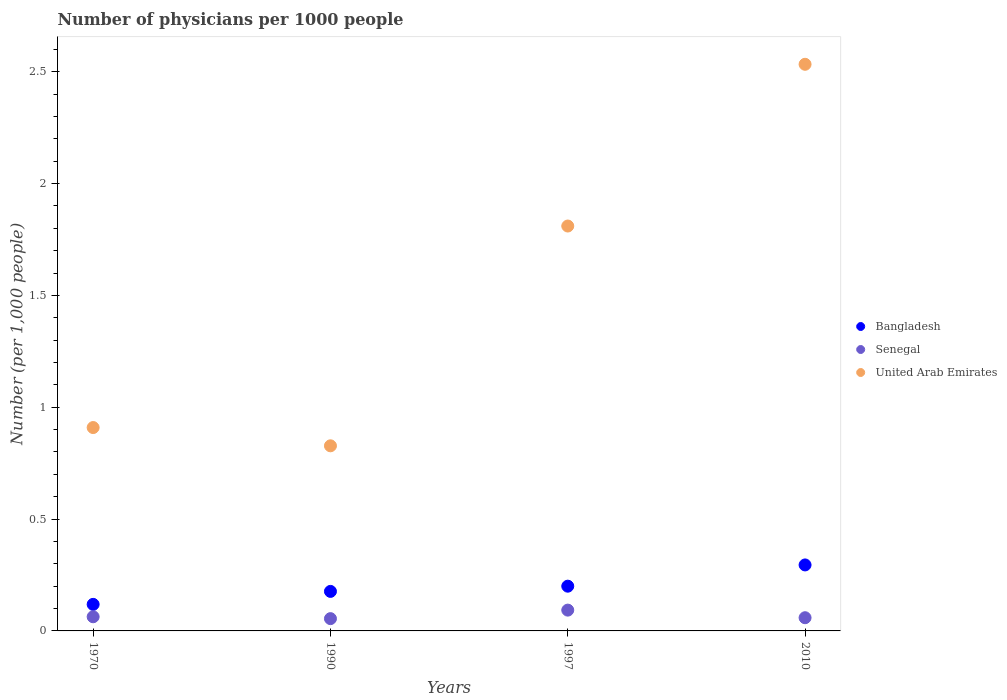What is the number of physicians in United Arab Emirates in 1970?
Your answer should be compact. 0.91. Across all years, what is the maximum number of physicians in United Arab Emirates?
Your answer should be compact. 2.53. Across all years, what is the minimum number of physicians in United Arab Emirates?
Your response must be concise. 0.83. In which year was the number of physicians in Senegal minimum?
Offer a terse response. 1990. What is the total number of physicians in United Arab Emirates in the graph?
Ensure brevity in your answer.  6.08. What is the difference between the number of physicians in Bangladesh in 1970 and that in 2010?
Provide a succinct answer. -0.18. What is the difference between the number of physicians in Bangladesh in 1970 and the number of physicians in United Arab Emirates in 1990?
Keep it short and to the point. -0.71. What is the average number of physicians in Senegal per year?
Ensure brevity in your answer.  0.07. In the year 1990, what is the difference between the number of physicians in United Arab Emirates and number of physicians in Senegal?
Offer a terse response. 0.77. In how many years, is the number of physicians in Bangladesh greater than 2.4?
Your answer should be very brief. 0. What is the ratio of the number of physicians in Bangladesh in 1970 to that in 2010?
Offer a terse response. 0.4. Is the number of physicians in Bangladesh in 1990 less than that in 2010?
Provide a succinct answer. Yes. Is the difference between the number of physicians in United Arab Emirates in 1970 and 2010 greater than the difference between the number of physicians in Senegal in 1970 and 2010?
Your answer should be compact. No. What is the difference between the highest and the second highest number of physicians in Senegal?
Give a very brief answer. 0.03. What is the difference between the highest and the lowest number of physicians in Bangladesh?
Make the answer very short. 0.18. Is the sum of the number of physicians in Senegal in 1990 and 1997 greater than the maximum number of physicians in United Arab Emirates across all years?
Keep it short and to the point. No. Does the number of physicians in Senegal monotonically increase over the years?
Make the answer very short. No. Is the number of physicians in Bangladesh strictly less than the number of physicians in United Arab Emirates over the years?
Give a very brief answer. Yes. How many years are there in the graph?
Make the answer very short. 4. Are the values on the major ticks of Y-axis written in scientific E-notation?
Offer a very short reply. No. Where does the legend appear in the graph?
Keep it short and to the point. Center right. What is the title of the graph?
Your answer should be compact. Number of physicians per 1000 people. What is the label or title of the X-axis?
Keep it short and to the point. Years. What is the label or title of the Y-axis?
Your response must be concise. Number (per 1,0 people). What is the Number (per 1,000 people) in Bangladesh in 1970?
Offer a very short reply. 0.12. What is the Number (per 1,000 people) of Senegal in 1970?
Your answer should be compact. 0.06. What is the Number (per 1,000 people) of United Arab Emirates in 1970?
Offer a very short reply. 0.91. What is the Number (per 1,000 people) of Bangladesh in 1990?
Offer a terse response. 0.18. What is the Number (per 1,000 people) of Senegal in 1990?
Give a very brief answer. 0.05. What is the Number (per 1,000 people) in United Arab Emirates in 1990?
Offer a terse response. 0.83. What is the Number (per 1,000 people) in Bangladesh in 1997?
Make the answer very short. 0.2. What is the Number (per 1,000 people) of Senegal in 1997?
Give a very brief answer. 0.09. What is the Number (per 1,000 people) in United Arab Emirates in 1997?
Provide a short and direct response. 1.81. What is the Number (per 1,000 people) of Bangladesh in 2010?
Offer a very short reply. 0.29. What is the Number (per 1,000 people) in Senegal in 2010?
Keep it short and to the point. 0.06. What is the Number (per 1,000 people) in United Arab Emirates in 2010?
Your answer should be compact. 2.53. Across all years, what is the maximum Number (per 1,000 people) of Bangladesh?
Ensure brevity in your answer.  0.29. Across all years, what is the maximum Number (per 1,000 people) in Senegal?
Provide a short and direct response. 0.09. Across all years, what is the maximum Number (per 1,000 people) in United Arab Emirates?
Offer a terse response. 2.53. Across all years, what is the minimum Number (per 1,000 people) in Bangladesh?
Your answer should be compact. 0.12. Across all years, what is the minimum Number (per 1,000 people) of Senegal?
Ensure brevity in your answer.  0.05. Across all years, what is the minimum Number (per 1,000 people) in United Arab Emirates?
Offer a very short reply. 0.83. What is the total Number (per 1,000 people) of Bangladesh in the graph?
Provide a short and direct response. 0.79. What is the total Number (per 1,000 people) of Senegal in the graph?
Your response must be concise. 0.27. What is the total Number (per 1,000 people) of United Arab Emirates in the graph?
Your answer should be compact. 6.08. What is the difference between the Number (per 1,000 people) in Bangladesh in 1970 and that in 1990?
Provide a succinct answer. -0.06. What is the difference between the Number (per 1,000 people) of Senegal in 1970 and that in 1990?
Give a very brief answer. 0.01. What is the difference between the Number (per 1,000 people) in United Arab Emirates in 1970 and that in 1990?
Provide a succinct answer. 0.08. What is the difference between the Number (per 1,000 people) in Bangladesh in 1970 and that in 1997?
Provide a short and direct response. -0.08. What is the difference between the Number (per 1,000 people) of Senegal in 1970 and that in 1997?
Give a very brief answer. -0.03. What is the difference between the Number (per 1,000 people) in United Arab Emirates in 1970 and that in 1997?
Your answer should be compact. -0.9. What is the difference between the Number (per 1,000 people) in Bangladesh in 1970 and that in 2010?
Ensure brevity in your answer.  -0.18. What is the difference between the Number (per 1,000 people) in Senegal in 1970 and that in 2010?
Your response must be concise. 0. What is the difference between the Number (per 1,000 people) in United Arab Emirates in 1970 and that in 2010?
Provide a short and direct response. -1.62. What is the difference between the Number (per 1,000 people) in Bangladesh in 1990 and that in 1997?
Your answer should be compact. -0.02. What is the difference between the Number (per 1,000 people) of Senegal in 1990 and that in 1997?
Keep it short and to the point. -0.04. What is the difference between the Number (per 1,000 people) in United Arab Emirates in 1990 and that in 1997?
Provide a short and direct response. -0.98. What is the difference between the Number (per 1,000 people) of Bangladesh in 1990 and that in 2010?
Give a very brief answer. -0.12. What is the difference between the Number (per 1,000 people) in Senegal in 1990 and that in 2010?
Provide a succinct answer. -0. What is the difference between the Number (per 1,000 people) of United Arab Emirates in 1990 and that in 2010?
Your response must be concise. -1.71. What is the difference between the Number (per 1,000 people) of Bangladesh in 1997 and that in 2010?
Your answer should be compact. -0.1. What is the difference between the Number (per 1,000 people) in Senegal in 1997 and that in 2010?
Make the answer very short. 0.03. What is the difference between the Number (per 1,000 people) in United Arab Emirates in 1997 and that in 2010?
Ensure brevity in your answer.  -0.72. What is the difference between the Number (per 1,000 people) of Bangladesh in 1970 and the Number (per 1,000 people) of Senegal in 1990?
Give a very brief answer. 0.06. What is the difference between the Number (per 1,000 people) in Bangladesh in 1970 and the Number (per 1,000 people) in United Arab Emirates in 1990?
Provide a succinct answer. -0.71. What is the difference between the Number (per 1,000 people) in Senegal in 1970 and the Number (per 1,000 people) in United Arab Emirates in 1990?
Provide a short and direct response. -0.76. What is the difference between the Number (per 1,000 people) in Bangladesh in 1970 and the Number (per 1,000 people) in Senegal in 1997?
Your answer should be compact. 0.03. What is the difference between the Number (per 1,000 people) of Bangladesh in 1970 and the Number (per 1,000 people) of United Arab Emirates in 1997?
Your answer should be compact. -1.69. What is the difference between the Number (per 1,000 people) in Senegal in 1970 and the Number (per 1,000 people) in United Arab Emirates in 1997?
Your answer should be compact. -1.75. What is the difference between the Number (per 1,000 people) in Bangladesh in 1970 and the Number (per 1,000 people) in Senegal in 2010?
Your answer should be very brief. 0.06. What is the difference between the Number (per 1,000 people) of Bangladesh in 1970 and the Number (per 1,000 people) of United Arab Emirates in 2010?
Offer a terse response. -2.41. What is the difference between the Number (per 1,000 people) of Senegal in 1970 and the Number (per 1,000 people) of United Arab Emirates in 2010?
Ensure brevity in your answer.  -2.47. What is the difference between the Number (per 1,000 people) of Bangladesh in 1990 and the Number (per 1,000 people) of Senegal in 1997?
Make the answer very short. 0.08. What is the difference between the Number (per 1,000 people) of Bangladesh in 1990 and the Number (per 1,000 people) of United Arab Emirates in 1997?
Offer a very short reply. -1.63. What is the difference between the Number (per 1,000 people) of Senegal in 1990 and the Number (per 1,000 people) of United Arab Emirates in 1997?
Make the answer very short. -1.76. What is the difference between the Number (per 1,000 people) of Bangladesh in 1990 and the Number (per 1,000 people) of Senegal in 2010?
Your answer should be very brief. 0.12. What is the difference between the Number (per 1,000 people) in Bangladesh in 1990 and the Number (per 1,000 people) in United Arab Emirates in 2010?
Your answer should be very brief. -2.36. What is the difference between the Number (per 1,000 people) in Senegal in 1990 and the Number (per 1,000 people) in United Arab Emirates in 2010?
Offer a very short reply. -2.48. What is the difference between the Number (per 1,000 people) of Bangladesh in 1997 and the Number (per 1,000 people) of Senegal in 2010?
Provide a succinct answer. 0.14. What is the difference between the Number (per 1,000 people) of Bangladesh in 1997 and the Number (per 1,000 people) of United Arab Emirates in 2010?
Your response must be concise. -2.33. What is the difference between the Number (per 1,000 people) in Senegal in 1997 and the Number (per 1,000 people) in United Arab Emirates in 2010?
Ensure brevity in your answer.  -2.44. What is the average Number (per 1,000 people) of Bangladesh per year?
Provide a short and direct response. 0.2. What is the average Number (per 1,000 people) in Senegal per year?
Offer a terse response. 0.07. What is the average Number (per 1,000 people) in United Arab Emirates per year?
Keep it short and to the point. 1.52. In the year 1970, what is the difference between the Number (per 1,000 people) in Bangladesh and Number (per 1,000 people) in Senegal?
Your answer should be very brief. 0.06. In the year 1970, what is the difference between the Number (per 1,000 people) in Bangladesh and Number (per 1,000 people) in United Arab Emirates?
Offer a very short reply. -0.79. In the year 1970, what is the difference between the Number (per 1,000 people) in Senegal and Number (per 1,000 people) in United Arab Emirates?
Keep it short and to the point. -0.85. In the year 1990, what is the difference between the Number (per 1,000 people) in Bangladesh and Number (per 1,000 people) in Senegal?
Ensure brevity in your answer.  0.12. In the year 1990, what is the difference between the Number (per 1,000 people) of Bangladesh and Number (per 1,000 people) of United Arab Emirates?
Your answer should be very brief. -0.65. In the year 1990, what is the difference between the Number (per 1,000 people) of Senegal and Number (per 1,000 people) of United Arab Emirates?
Your answer should be very brief. -0.77. In the year 1997, what is the difference between the Number (per 1,000 people) in Bangladesh and Number (per 1,000 people) in Senegal?
Keep it short and to the point. 0.11. In the year 1997, what is the difference between the Number (per 1,000 people) of Bangladesh and Number (per 1,000 people) of United Arab Emirates?
Provide a succinct answer. -1.61. In the year 1997, what is the difference between the Number (per 1,000 people) of Senegal and Number (per 1,000 people) of United Arab Emirates?
Make the answer very short. -1.72. In the year 2010, what is the difference between the Number (per 1,000 people) of Bangladesh and Number (per 1,000 people) of Senegal?
Provide a succinct answer. 0.24. In the year 2010, what is the difference between the Number (per 1,000 people) in Bangladesh and Number (per 1,000 people) in United Arab Emirates?
Offer a terse response. -2.24. In the year 2010, what is the difference between the Number (per 1,000 people) of Senegal and Number (per 1,000 people) of United Arab Emirates?
Provide a succinct answer. -2.47. What is the ratio of the Number (per 1,000 people) of Bangladesh in 1970 to that in 1990?
Make the answer very short. 0.67. What is the ratio of the Number (per 1,000 people) in Senegal in 1970 to that in 1990?
Give a very brief answer. 1.15. What is the ratio of the Number (per 1,000 people) in United Arab Emirates in 1970 to that in 1990?
Ensure brevity in your answer.  1.1. What is the ratio of the Number (per 1,000 people) of Bangladesh in 1970 to that in 1997?
Offer a very short reply. 0.59. What is the ratio of the Number (per 1,000 people) in Senegal in 1970 to that in 1997?
Offer a terse response. 0.68. What is the ratio of the Number (per 1,000 people) of United Arab Emirates in 1970 to that in 1997?
Offer a terse response. 0.5. What is the ratio of the Number (per 1,000 people) of Bangladesh in 1970 to that in 2010?
Your answer should be very brief. 0.4. What is the ratio of the Number (per 1,000 people) in Senegal in 1970 to that in 2010?
Ensure brevity in your answer.  1.07. What is the ratio of the Number (per 1,000 people) in United Arab Emirates in 1970 to that in 2010?
Provide a succinct answer. 0.36. What is the ratio of the Number (per 1,000 people) in Bangladesh in 1990 to that in 1997?
Give a very brief answer. 0.88. What is the ratio of the Number (per 1,000 people) of Senegal in 1990 to that in 1997?
Ensure brevity in your answer.  0.59. What is the ratio of the Number (per 1,000 people) of United Arab Emirates in 1990 to that in 1997?
Offer a terse response. 0.46. What is the ratio of the Number (per 1,000 people) of Bangladesh in 1990 to that in 2010?
Make the answer very short. 0.6. What is the ratio of the Number (per 1,000 people) in Senegal in 1990 to that in 2010?
Your answer should be compact. 0.93. What is the ratio of the Number (per 1,000 people) of United Arab Emirates in 1990 to that in 2010?
Your answer should be very brief. 0.33. What is the ratio of the Number (per 1,000 people) of Bangladesh in 1997 to that in 2010?
Offer a very short reply. 0.68. What is the ratio of the Number (per 1,000 people) in Senegal in 1997 to that in 2010?
Keep it short and to the point. 1.58. What is the ratio of the Number (per 1,000 people) of United Arab Emirates in 1997 to that in 2010?
Provide a succinct answer. 0.71. What is the difference between the highest and the second highest Number (per 1,000 people) of Bangladesh?
Offer a terse response. 0.1. What is the difference between the highest and the second highest Number (per 1,000 people) in Senegal?
Ensure brevity in your answer.  0.03. What is the difference between the highest and the second highest Number (per 1,000 people) in United Arab Emirates?
Provide a succinct answer. 0.72. What is the difference between the highest and the lowest Number (per 1,000 people) of Bangladesh?
Provide a succinct answer. 0.18. What is the difference between the highest and the lowest Number (per 1,000 people) in Senegal?
Your response must be concise. 0.04. What is the difference between the highest and the lowest Number (per 1,000 people) of United Arab Emirates?
Your answer should be compact. 1.71. 